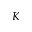Convert formula to latex. <formula><loc_0><loc_0><loc_500><loc_500>K</formula> 